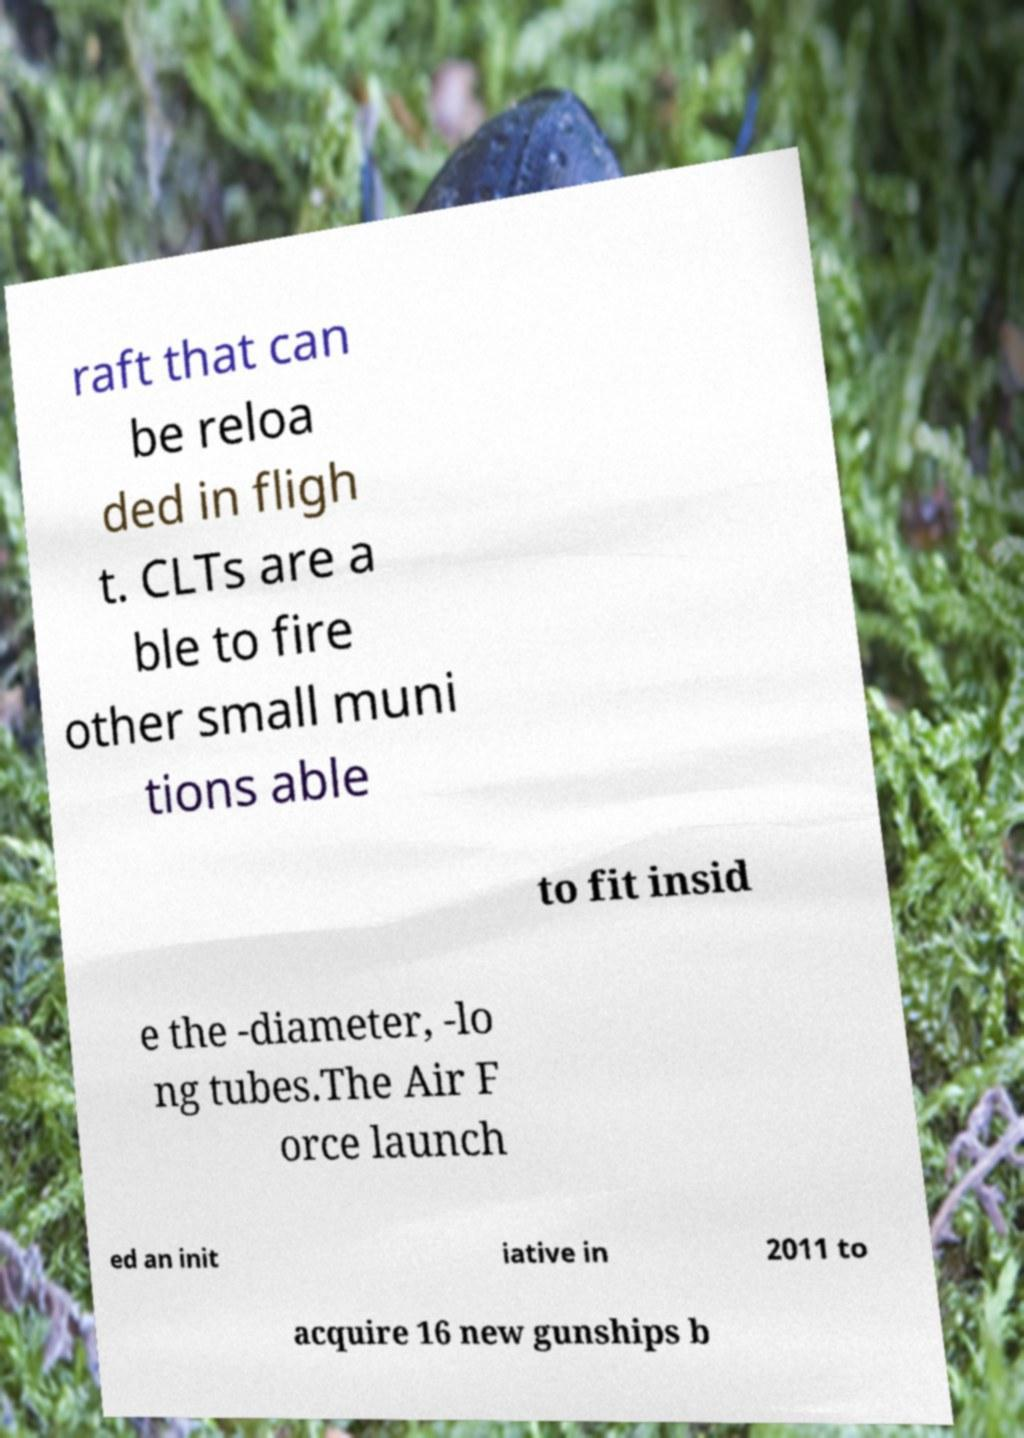Could you extract and type out the text from this image? raft that can be reloa ded in fligh t. CLTs are a ble to fire other small muni tions able to fit insid e the -diameter, -lo ng tubes.The Air F orce launch ed an init iative in 2011 to acquire 16 new gunships b 